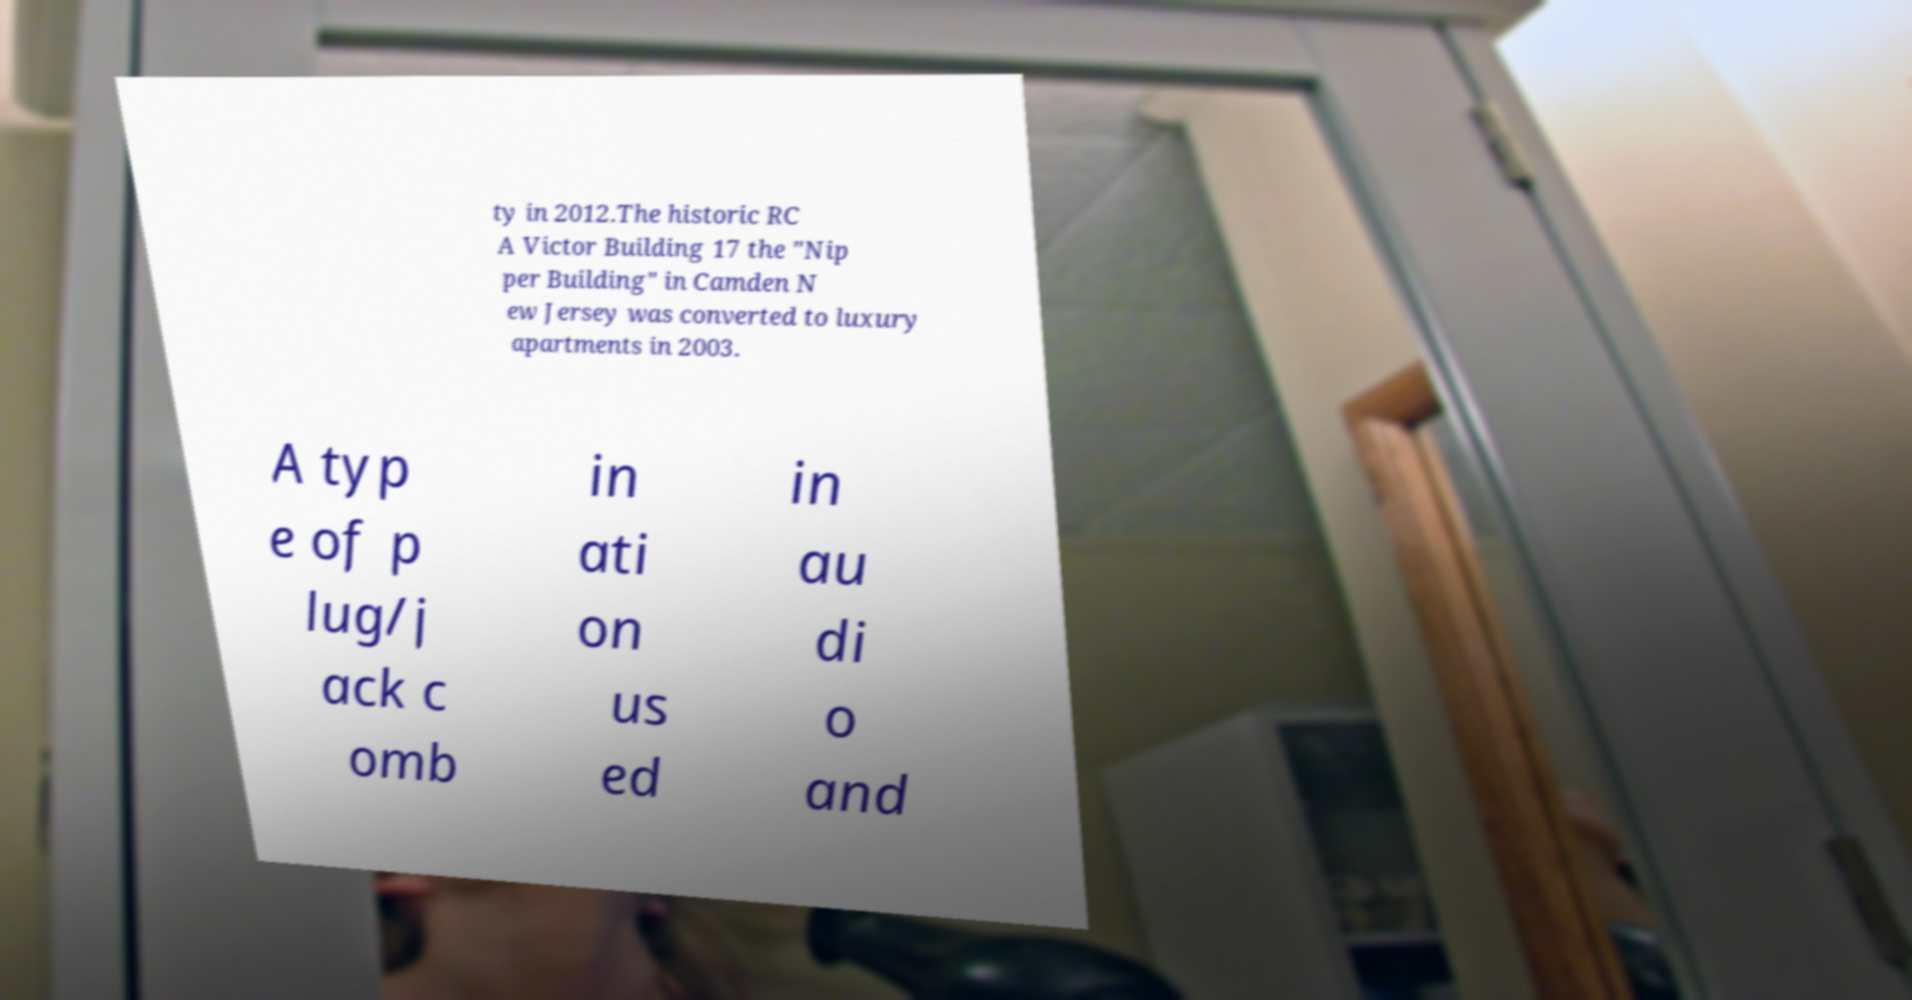Can you read and provide the text displayed in the image?This photo seems to have some interesting text. Can you extract and type it out for me? ty in 2012.The historic RC A Victor Building 17 the "Nip per Building" in Camden N ew Jersey was converted to luxury apartments in 2003. A typ e of p lug/j ack c omb in ati on us ed in au di o and 